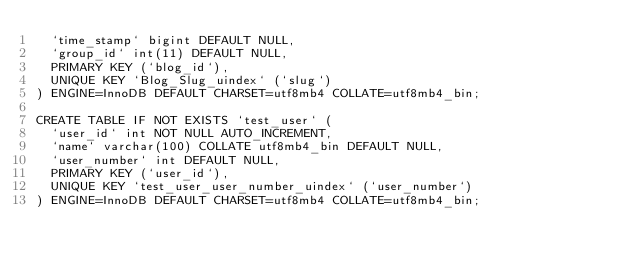Convert code to text. <code><loc_0><loc_0><loc_500><loc_500><_SQL_>  `time_stamp` bigint DEFAULT NULL,
  `group_id` int(11) DEFAULT NULL,
  PRIMARY KEY (`blog_id`),
  UNIQUE KEY `Blog_Slug_uindex` (`slug`)
) ENGINE=InnoDB DEFAULT CHARSET=utf8mb4 COLLATE=utf8mb4_bin;

CREATE TABLE IF NOT EXISTS `test_user` (
  `user_id` int NOT NULL AUTO_INCREMENT,
  `name` varchar(100) COLLATE utf8mb4_bin DEFAULT NULL,
  `user_number` int DEFAULT NULL,
  PRIMARY KEY (`user_id`),
  UNIQUE KEY `test_user_user_number_uindex` (`user_number`)
) ENGINE=InnoDB DEFAULT CHARSET=utf8mb4 COLLATE=utf8mb4_bin;

</code> 